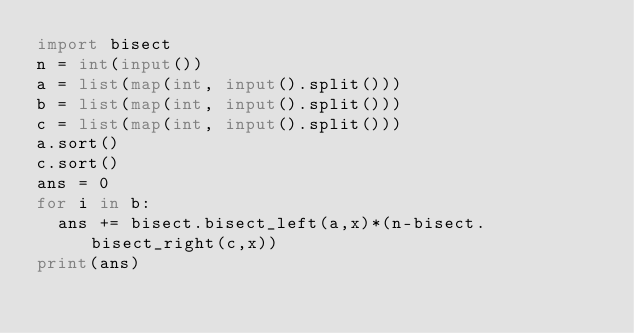Convert code to text. <code><loc_0><loc_0><loc_500><loc_500><_Python_>import bisect
n = int(input())
a = list(map(int, input().split()))
b = list(map(int, input().split()))
c = list(map(int, input().split()))
a.sort()
c.sort()
ans = 0
for i in b:
  ans += bisect.bisect_left(a,x)*(n-bisect.bisect_right(c,x))
print(ans)</code> 